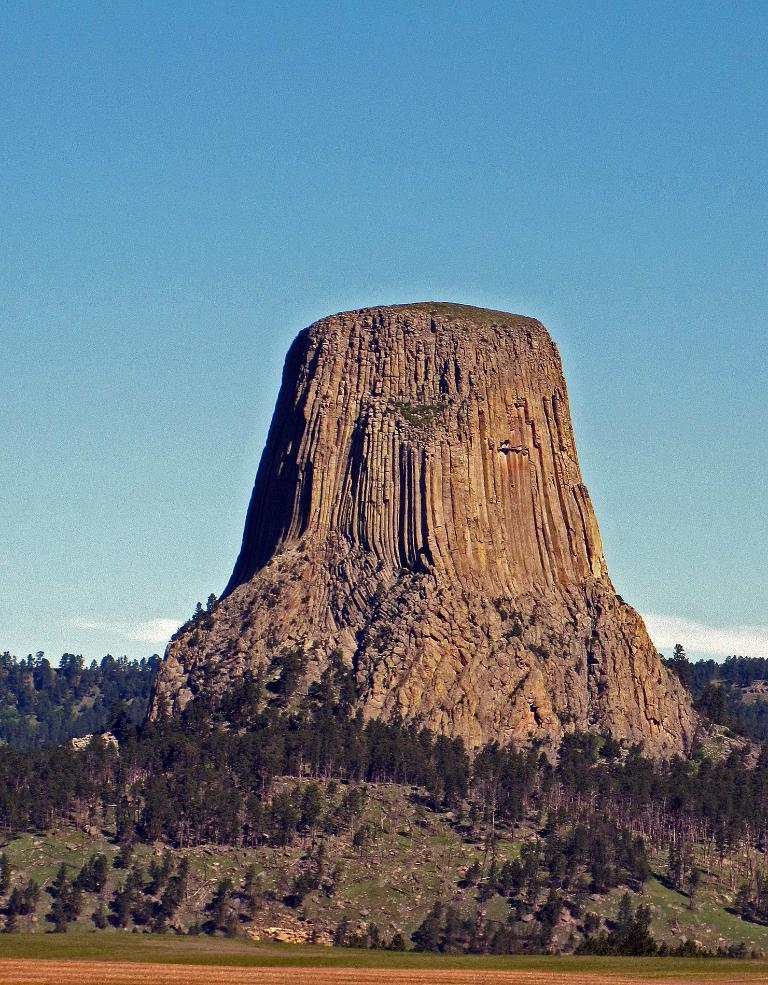What type of landscape is depicted in the image? There is a grassland in the image. What other natural features can be seen in the image? There are trees and hills in the image. What famous landmark is visible in the image? Devil's Tower is visible in the image. What is the color of the sky in the background? The sky is blue in the background. Are there any weather conditions visible in the image? Clouds are present in the sky. What type of insurance policy is being discussed by the trees in the image? There are no trees discussing insurance policies in the image; they are simply part of the natural landscape. 